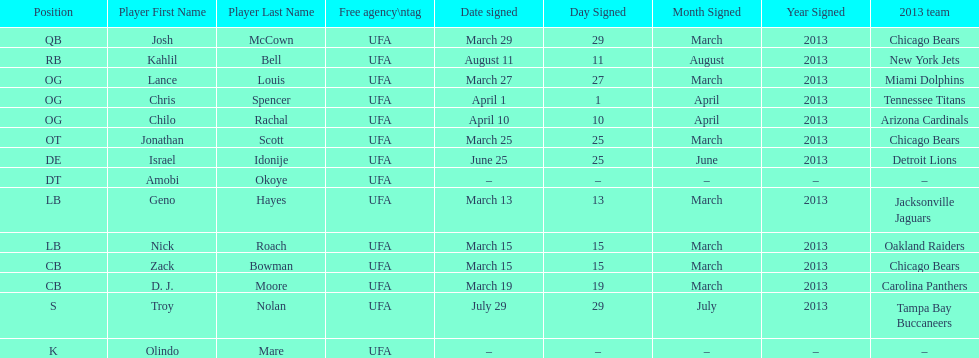Total number of players that signed in march? 7. 